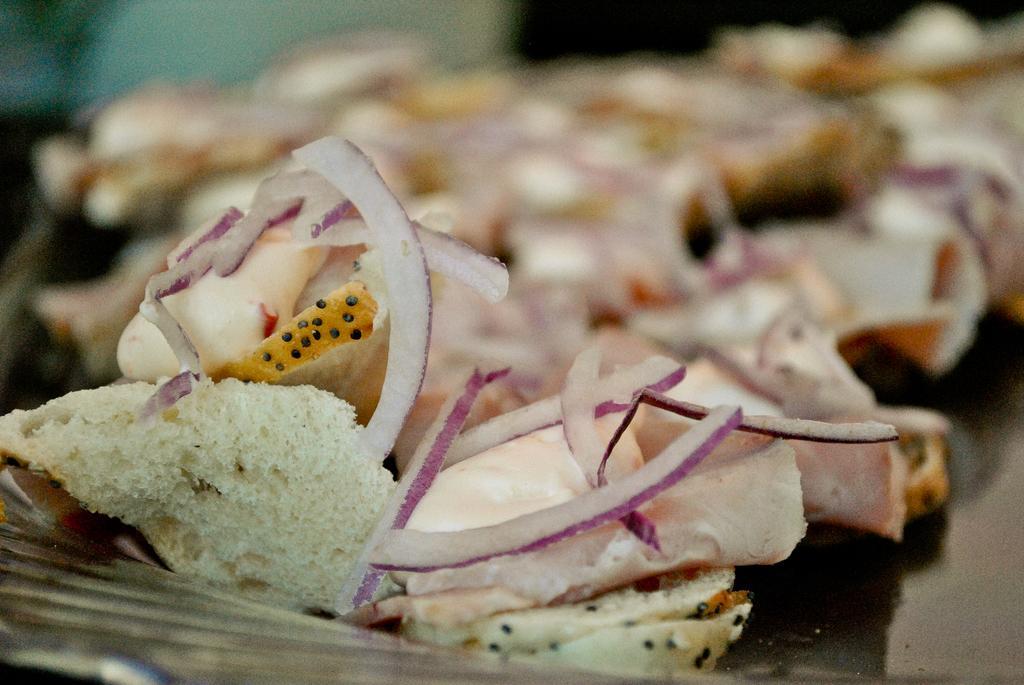Describe this image in one or two sentences. In this image I can see a food on the black surface. Food is in white,yellow,black color and it is blurred. 